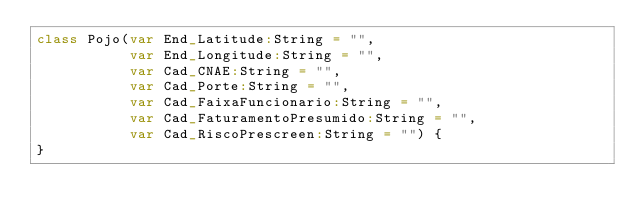<code> <loc_0><loc_0><loc_500><loc_500><_Scala_>class Pojo(var End_Latitude:String = "",
           var End_Longitude:String = "",
           var Cad_CNAE:String = "",
           var Cad_Porte:String = "",
           var Cad_FaixaFuncionario:String = "",
           var Cad_FaturamentoPresumido:String = "",
           var Cad_RiscoPrescreen:String = "") {
}</code> 